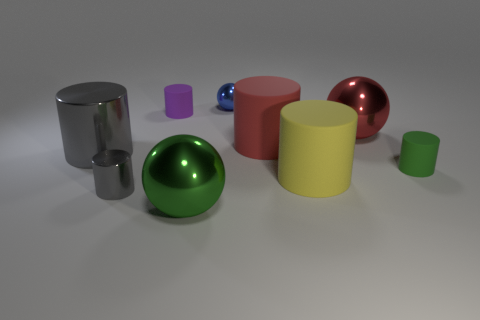Is the number of large red cubes less than the number of gray cylinders?
Provide a short and direct response. Yes. How many rubber things are either brown cubes or small balls?
Your answer should be very brief. 0. There is a small matte cylinder on the left side of the large green shiny sphere; are there any cylinders that are on the right side of it?
Your answer should be compact. Yes. Are the big thing that is in front of the yellow thing and the tiny gray object made of the same material?
Offer a very short reply. Yes. What number of other objects are the same color as the small metal cylinder?
Provide a short and direct response. 1. Do the tiny sphere and the tiny metallic cylinder have the same color?
Provide a succinct answer. No. There is a metal object that is behind the big sphere that is behind the big green object; what is its size?
Offer a very short reply. Small. Are the green object on the right side of the green shiny object and the tiny thing behind the purple cylinder made of the same material?
Give a very brief answer. No. There is a cylinder in front of the big yellow cylinder; does it have the same color as the big shiny cylinder?
Keep it short and to the point. Yes. There is a large red metal sphere; how many big red metallic balls are to the right of it?
Give a very brief answer. 0. 